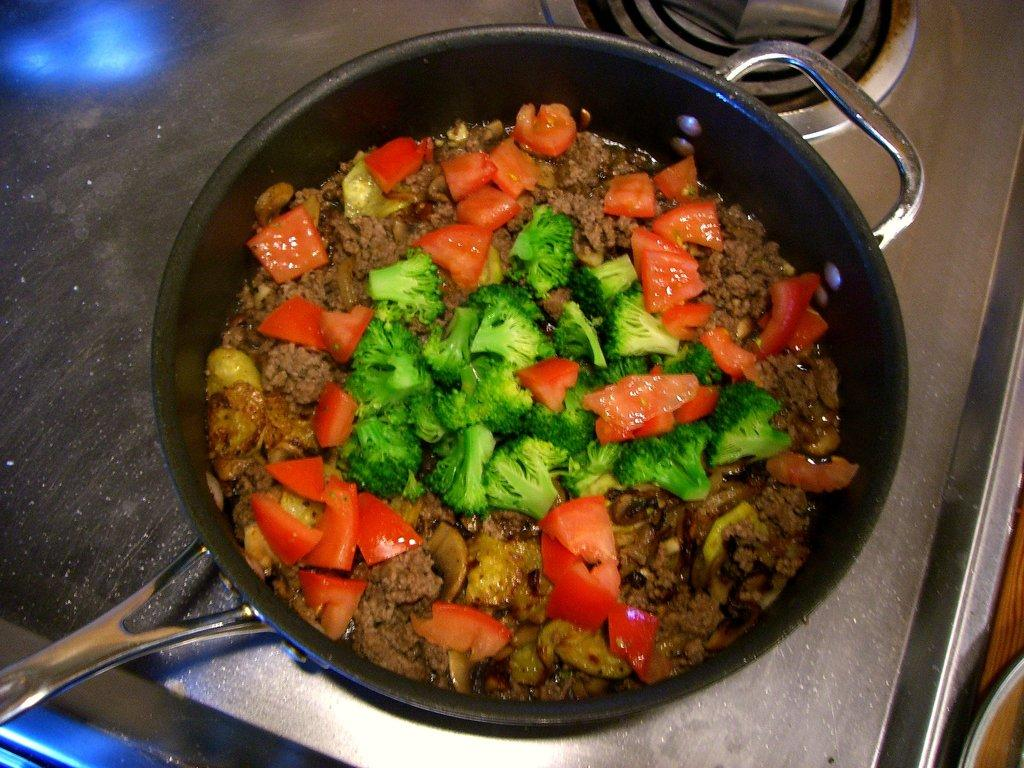What type of food can be seen in the image? There is a group of vegetables in the image. How are the vegetables and food arranged in the image? The vegetables and food are placed in a pan. Where is the pan located in the image? The pan is kept on a stove. What type of tent is set up near the stove in the image? There is no tent present in the image; it features a pan of vegetables and food on a stove. 